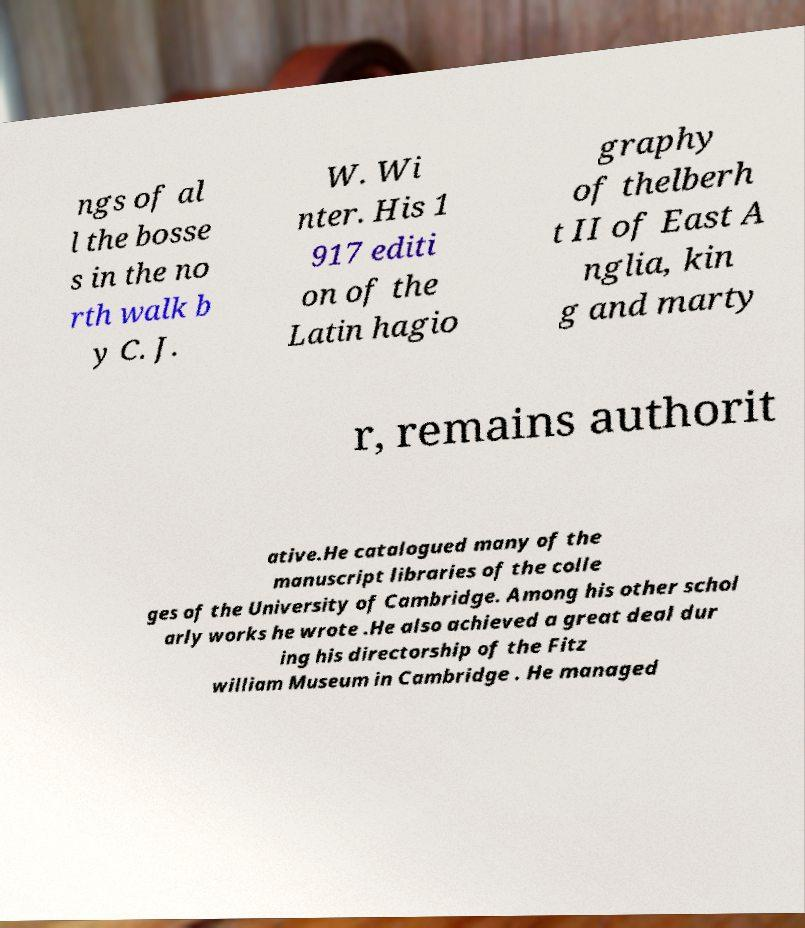What messages or text are displayed in this image? I need them in a readable, typed format. ngs of al l the bosse s in the no rth walk b y C. J. W. Wi nter. His 1 917 editi on of the Latin hagio graphy of thelberh t II of East A nglia, kin g and marty r, remains authorit ative.He catalogued many of the manuscript libraries of the colle ges of the University of Cambridge. Among his other schol arly works he wrote .He also achieved a great deal dur ing his directorship of the Fitz william Museum in Cambridge . He managed 